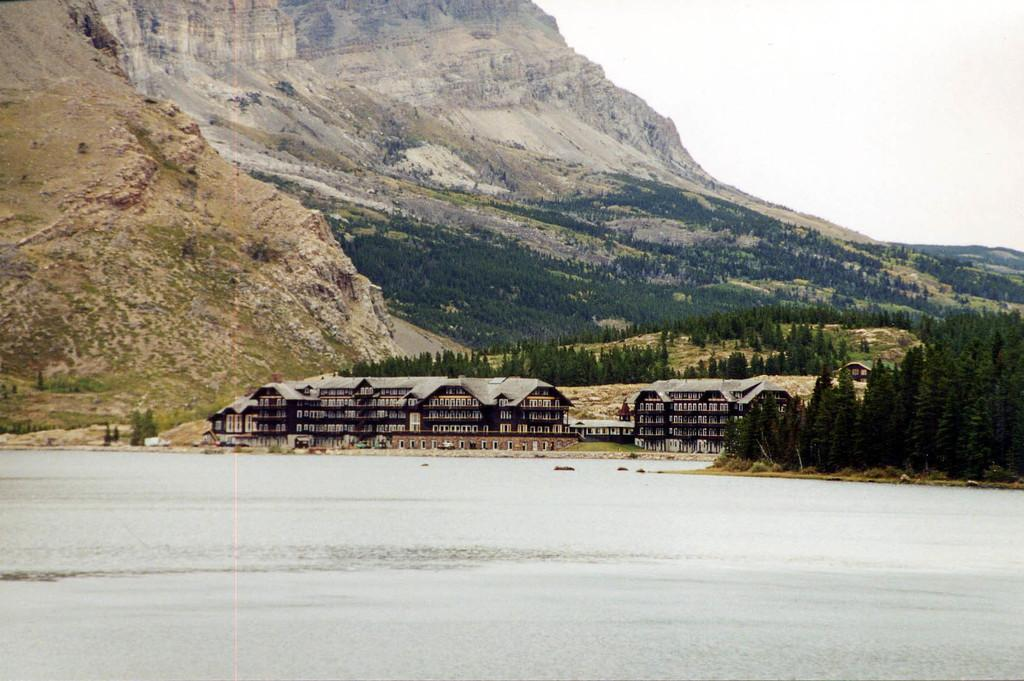What type of structures can be seen in the image? There are buildings in the image. What other natural elements are present in the image? There are trees in the image. What can be seen in the distance in the background of the image? There are mountains visible in the background of the image. What is at the bottom of the image? There is water at the bottom of the image. What is visible at the top of the image? The sky is visible at the top of the image. Where is the shelf located in the image? There is no shelf present in the image. Can you see a pig in the image? There is no pig present in the image. 